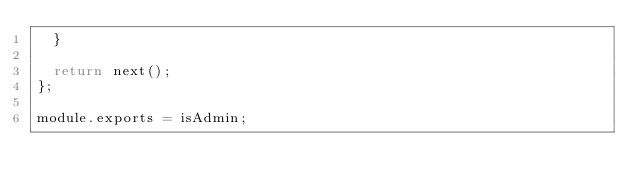<code> <loc_0><loc_0><loc_500><loc_500><_JavaScript_>  }

  return next();
};

module.exports = isAdmin;
</code> 